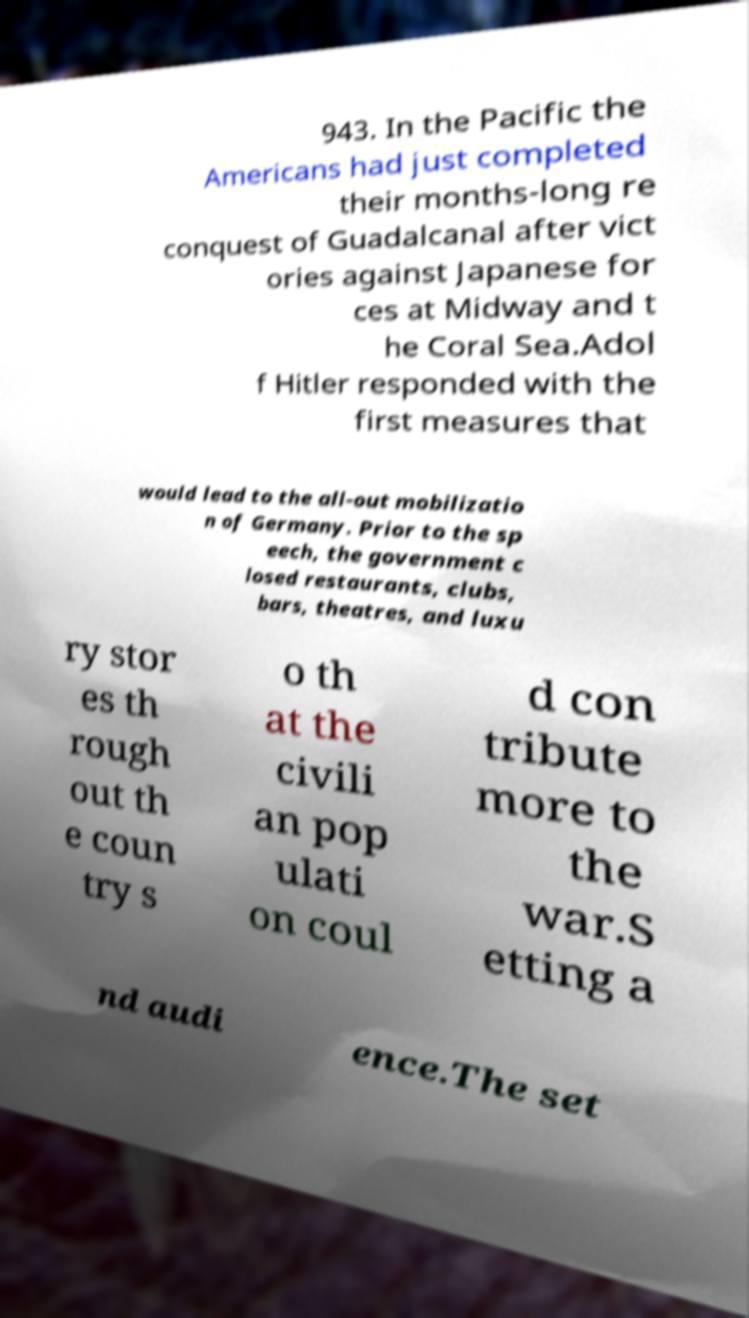What messages or text are displayed in this image? I need them in a readable, typed format. 943. In the Pacific the Americans had just completed their months-long re conquest of Guadalcanal after vict ories against Japanese for ces at Midway and t he Coral Sea.Adol f Hitler responded with the first measures that would lead to the all-out mobilizatio n of Germany. Prior to the sp eech, the government c losed restaurants, clubs, bars, theatres, and luxu ry stor es th rough out th e coun try s o th at the civili an pop ulati on coul d con tribute more to the war.S etting a nd audi ence.The set 